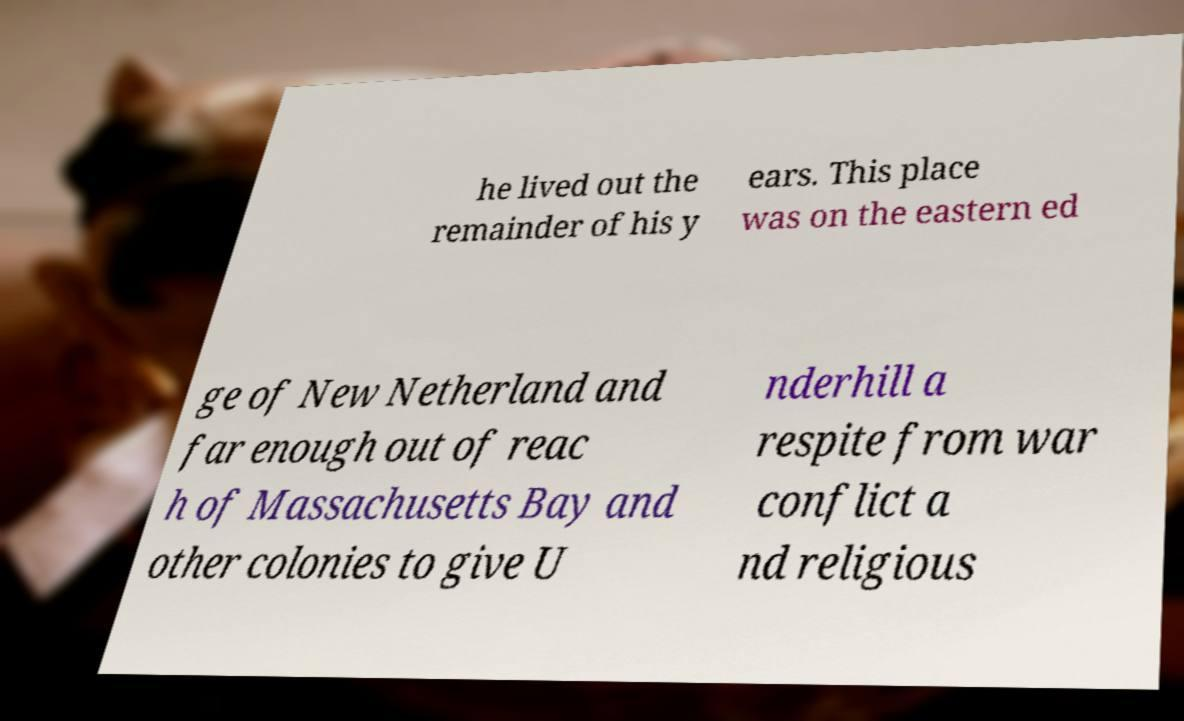Please read and relay the text visible in this image. What does it say? he lived out the remainder of his y ears. This place was on the eastern ed ge of New Netherland and far enough out of reac h of Massachusetts Bay and other colonies to give U nderhill a respite from war conflict a nd religious 